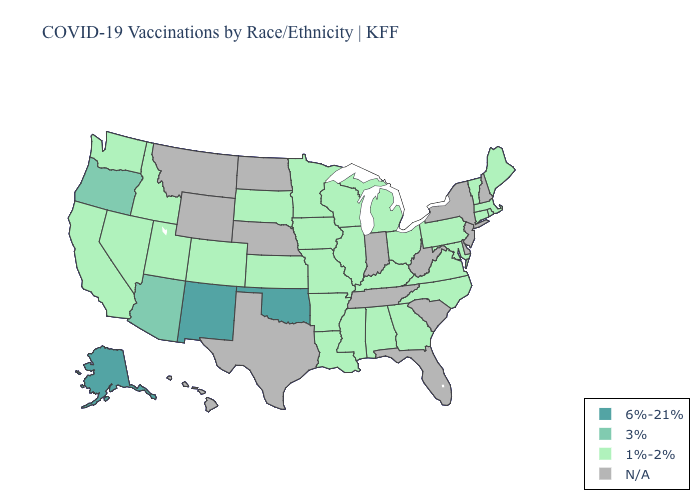How many symbols are there in the legend?
Quick response, please. 4. What is the lowest value in the USA?
Give a very brief answer. 1%-2%. What is the highest value in the USA?
Be succinct. 6%-21%. What is the highest value in states that border Florida?
Keep it brief. 1%-2%. Name the states that have a value in the range N/A?
Quick response, please. Delaware, Florida, Hawaii, Indiana, Montana, Nebraska, New Hampshire, New Jersey, New York, North Dakota, South Carolina, Tennessee, Texas, West Virginia, Wyoming. What is the highest value in states that border Alabama?
Concise answer only. 1%-2%. Is the legend a continuous bar?
Write a very short answer. No. What is the value of Oklahoma?
Be succinct. 6%-21%. What is the value of Kentucky?
Short answer required. 1%-2%. Does Kansas have the lowest value in the USA?
Give a very brief answer. Yes. Does Arizona have the highest value in the USA?
Give a very brief answer. No. Which states have the highest value in the USA?
Quick response, please. Alaska, New Mexico, Oklahoma. Among the states that border West Virginia , which have the lowest value?
Keep it brief. Kentucky, Maryland, Ohio, Pennsylvania, Virginia. 